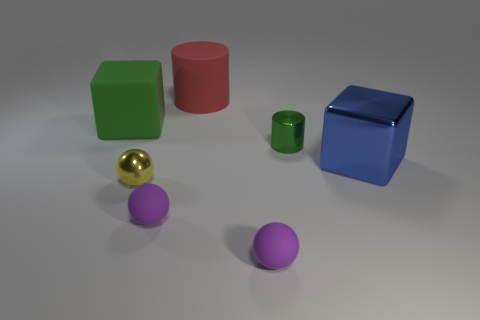How many objects are either rubber cylinders or blue spheres?
Ensure brevity in your answer.  1. Does the block that is to the right of the large matte block have the same material as the tiny object behind the metallic block?
Your answer should be very brief. Yes. What is the color of the big cube that is made of the same material as the red cylinder?
Your response must be concise. Green. What number of cylinders have the same size as the rubber cube?
Give a very brief answer. 1. How many other objects are the same color as the large metal cube?
Ensure brevity in your answer.  0. There is a tiny green object to the left of the blue shiny cube; is it the same shape as the big matte thing that is on the right side of the yellow metallic object?
Keep it short and to the point. Yes. What shape is the shiny object that is the same size as the yellow ball?
Offer a very short reply. Cylinder. Are there the same number of large blue things that are behind the large cylinder and tiny green metallic things that are behind the large green rubber object?
Keep it short and to the point. Yes. Do the block that is to the left of the red matte cylinder and the blue object have the same material?
Your answer should be very brief. No. There is a yellow ball that is the same size as the metal cylinder; what is it made of?
Your answer should be compact. Metal. 